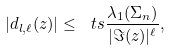<formula> <loc_0><loc_0><loc_500><loc_500>| d _ { l , \ell } ( z ) | \leq \ t s \frac { \lambda _ { 1 } ( \Sigma _ { n } ) } { | \Im ( z ) | ^ { \ell } } ,</formula> 